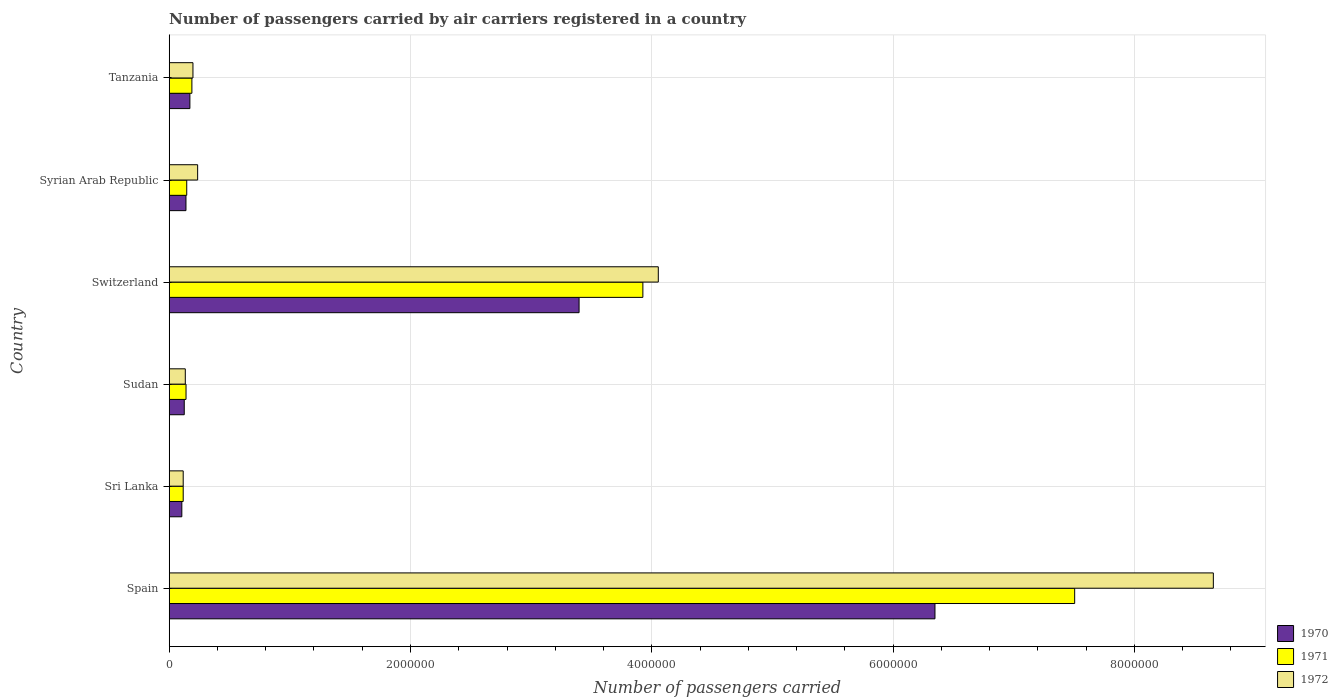Are the number of bars on each tick of the Y-axis equal?
Make the answer very short. Yes. How many bars are there on the 4th tick from the bottom?
Provide a short and direct response. 3. What is the label of the 4th group of bars from the top?
Offer a very short reply. Sudan. What is the number of passengers carried by air carriers in 1972 in Syrian Arab Republic?
Your response must be concise. 2.36e+05. Across all countries, what is the maximum number of passengers carried by air carriers in 1971?
Make the answer very short. 7.51e+06. Across all countries, what is the minimum number of passengers carried by air carriers in 1970?
Your response must be concise. 1.05e+05. In which country was the number of passengers carried by air carriers in 1971 minimum?
Give a very brief answer. Sri Lanka. What is the total number of passengers carried by air carriers in 1970 in the graph?
Make the answer very short. 1.03e+07. What is the difference between the number of passengers carried by air carriers in 1972 in Switzerland and that in Tanzania?
Keep it short and to the point. 3.86e+06. What is the difference between the number of passengers carried by air carriers in 1972 in Sri Lanka and the number of passengers carried by air carriers in 1971 in Syrian Arab Republic?
Offer a terse response. -2.93e+04. What is the average number of passengers carried by air carriers in 1971 per country?
Your response must be concise. 2.00e+06. What is the difference between the number of passengers carried by air carriers in 1970 and number of passengers carried by air carriers in 1972 in Syrian Arab Republic?
Make the answer very short. -9.67e+04. In how many countries, is the number of passengers carried by air carriers in 1970 greater than 7200000 ?
Ensure brevity in your answer.  0. What is the ratio of the number of passengers carried by air carriers in 1972 in Spain to that in Syrian Arab Republic?
Your answer should be very brief. 36.72. Is the difference between the number of passengers carried by air carriers in 1970 in Sudan and Switzerland greater than the difference between the number of passengers carried by air carriers in 1972 in Sudan and Switzerland?
Offer a very short reply. Yes. What is the difference between the highest and the second highest number of passengers carried by air carriers in 1970?
Provide a succinct answer. 2.95e+06. What is the difference between the highest and the lowest number of passengers carried by air carriers in 1970?
Your response must be concise. 6.24e+06. In how many countries, is the number of passengers carried by air carriers in 1970 greater than the average number of passengers carried by air carriers in 1970 taken over all countries?
Provide a short and direct response. 2. What is the difference between two consecutive major ticks on the X-axis?
Keep it short and to the point. 2.00e+06. Are the values on the major ticks of X-axis written in scientific E-notation?
Your answer should be very brief. No. Does the graph contain grids?
Your answer should be very brief. Yes. What is the title of the graph?
Offer a terse response. Number of passengers carried by air carriers registered in a country. What is the label or title of the X-axis?
Offer a very short reply. Number of passengers carried. What is the label or title of the Y-axis?
Give a very brief answer. Country. What is the Number of passengers carried of 1970 in Spain?
Make the answer very short. 6.35e+06. What is the Number of passengers carried in 1971 in Spain?
Provide a succinct answer. 7.51e+06. What is the Number of passengers carried of 1972 in Spain?
Keep it short and to the point. 8.65e+06. What is the Number of passengers carried of 1970 in Sri Lanka?
Your response must be concise. 1.05e+05. What is the Number of passengers carried of 1971 in Sri Lanka?
Keep it short and to the point. 1.16e+05. What is the Number of passengers carried in 1972 in Sri Lanka?
Give a very brief answer. 1.16e+05. What is the Number of passengers carried in 1970 in Sudan?
Give a very brief answer. 1.25e+05. What is the Number of passengers carried in 1971 in Sudan?
Your response must be concise. 1.40e+05. What is the Number of passengers carried in 1972 in Sudan?
Make the answer very short. 1.33e+05. What is the Number of passengers carried of 1970 in Switzerland?
Your answer should be compact. 3.40e+06. What is the Number of passengers carried in 1971 in Switzerland?
Offer a terse response. 3.93e+06. What is the Number of passengers carried in 1972 in Switzerland?
Offer a very short reply. 4.05e+06. What is the Number of passengers carried in 1970 in Syrian Arab Republic?
Provide a succinct answer. 1.39e+05. What is the Number of passengers carried of 1971 in Syrian Arab Republic?
Ensure brevity in your answer.  1.45e+05. What is the Number of passengers carried of 1972 in Syrian Arab Republic?
Provide a short and direct response. 2.36e+05. What is the Number of passengers carried in 1970 in Tanzania?
Offer a terse response. 1.71e+05. What is the Number of passengers carried of 1971 in Tanzania?
Keep it short and to the point. 1.88e+05. What is the Number of passengers carried of 1972 in Tanzania?
Ensure brevity in your answer.  1.97e+05. Across all countries, what is the maximum Number of passengers carried of 1970?
Your answer should be compact. 6.35e+06. Across all countries, what is the maximum Number of passengers carried in 1971?
Your response must be concise. 7.51e+06. Across all countries, what is the maximum Number of passengers carried of 1972?
Your response must be concise. 8.65e+06. Across all countries, what is the minimum Number of passengers carried in 1970?
Your answer should be very brief. 1.05e+05. Across all countries, what is the minimum Number of passengers carried in 1971?
Give a very brief answer. 1.16e+05. Across all countries, what is the minimum Number of passengers carried in 1972?
Provide a short and direct response. 1.16e+05. What is the total Number of passengers carried in 1970 in the graph?
Offer a very short reply. 1.03e+07. What is the total Number of passengers carried in 1971 in the graph?
Provide a succinct answer. 1.20e+07. What is the total Number of passengers carried in 1972 in the graph?
Keep it short and to the point. 1.34e+07. What is the difference between the Number of passengers carried of 1970 in Spain and that in Sri Lanka?
Offer a very short reply. 6.24e+06. What is the difference between the Number of passengers carried of 1971 in Spain and that in Sri Lanka?
Your response must be concise. 7.39e+06. What is the difference between the Number of passengers carried in 1972 in Spain and that in Sri Lanka?
Make the answer very short. 8.54e+06. What is the difference between the Number of passengers carried in 1970 in Spain and that in Sudan?
Provide a succinct answer. 6.22e+06. What is the difference between the Number of passengers carried of 1971 in Spain and that in Sudan?
Keep it short and to the point. 7.37e+06. What is the difference between the Number of passengers carried in 1972 in Spain and that in Sudan?
Ensure brevity in your answer.  8.52e+06. What is the difference between the Number of passengers carried of 1970 in Spain and that in Switzerland?
Your answer should be very brief. 2.95e+06. What is the difference between the Number of passengers carried in 1971 in Spain and that in Switzerland?
Give a very brief answer. 3.58e+06. What is the difference between the Number of passengers carried of 1972 in Spain and that in Switzerland?
Offer a very short reply. 4.60e+06. What is the difference between the Number of passengers carried in 1970 in Spain and that in Syrian Arab Republic?
Your answer should be very brief. 6.21e+06. What is the difference between the Number of passengers carried in 1971 in Spain and that in Syrian Arab Republic?
Provide a short and direct response. 7.36e+06. What is the difference between the Number of passengers carried in 1972 in Spain and that in Syrian Arab Republic?
Offer a very short reply. 8.42e+06. What is the difference between the Number of passengers carried in 1970 in Spain and that in Tanzania?
Ensure brevity in your answer.  6.18e+06. What is the difference between the Number of passengers carried in 1971 in Spain and that in Tanzania?
Offer a terse response. 7.32e+06. What is the difference between the Number of passengers carried in 1972 in Spain and that in Tanzania?
Offer a very short reply. 8.46e+06. What is the difference between the Number of passengers carried of 1970 in Sri Lanka and that in Sudan?
Ensure brevity in your answer.  -2.01e+04. What is the difference between the Number of passengers carried of 1971 in Sri Lanka and that in Sudan?
Ensure brevity in your answer.  -2.35e+04. What is the difference between the Number of passengers carried of 1972 in Sri Lanka and that in Sudan?
Give a very brief answer. -1.74e+04. What is the difference between the Number of passengers carried in 1970 in Sri Lanka and that in Switzerland?
Make the answer very short. -3.29e+06. What is the difference between the Number of passengers carried of 1971 in Sri Lanka and that in Switzerland?
Ensure brevity in your answer.  -3.81e+06. What is the difference between the Number of passengers carried in 1972 in Sri Lanka and that in Switzerland?
Provide a short and direct response. -3.94e+06. What is the difference between the Number of passengers carried in 1970 in Sri Lanka and that in Syrian Arab Republic?
Your response must be concise. -3.44e+04. What is the difference between the Number of passengers carried in 1971 in Sri Lanka and that in Syrian Arab Republic?
Your answer should be compact. -2.93e+04. What is the difference between the Number of passengers carried of 1972 in Sri Lanka and that in Syrian Arab Republic?
Offer a very short reply. -1.20e+05. What is the difference between the Number of passengers carried of 1970 in Sri Lanka and that in Tanzania?
Give a very brief answer. -6.68e+04. What is the difference between the Number of passengers carried of 1971 in Sri Lanka and that in Tanzania?
Provide a short and direct response. -7.20e+04. What is the difference between the Number of passengers carried in 1972 in Sri Lanka and that in Tanzania?
Keep it short and to the point. -8.09e+04. What is the difference between the Number of passengers carried in 1970 in Sudan and that in Switzerland?
Make the answer very short. -3.27e+06. What is the difference between the Number of passengers carried in 1971 in Sudan and that in Switzerland?
Provide a succinct answer. -3.79e+06. What is the difference between the Number of passengers carried in 1972 in Sudan and that in Switzerland?
Keep it short and to the point. -3.92e+06. What is the difference between the Number of passengers carried in 1970 in Sudan and that in Syrian Arab Republic?
Provide a succinct answer. -1.43e+04. What is the difference between the Number of passengers carried of 1971 in Sudan and that in Syrian Arab Republic?
Offer a terse response. -5800. What is the difference between the Number of passengers carried of 1972 in Sudan and that in Syrian Arab Republic?
Offer a terse response. -1.02e+05. What is the difference between the Number of passengers carried of 1970 in Sudan and that in Tanzania?
Ensure brevity in your answer.  -4.67e+04. What is the difference between the Number of passengers carried in 1971 in Sudan and that in Tanzania?
Provide a short and direct response. -4.85e+04. What is the difference between the Number of passengers carried of 1972 in Sudan and that in Tanzania?
Offer a very short reply. -6.35e+04. What is the difference between the Number of passengers carried of 1970 in Switzerland and that in Syrian Arab Republic?
Offer a terse response. 3.26e+06. What is the difference between the Number of passengers carried of 1971 in Switzerland and that in Syrian Arab Republic?
Ensure brevity in your answer.  3.78e+06. What is the difference between the Number of passengers carried of 1972 in Switzerland and that in Syrian Arab Republic?
Your answer should be very brief. 3.82e+06. What is the difference between the Number of passengers carried in 1970 in Switzerland and that in Tanzania?
Keep it short and to the point. 3.23e+06. What is the difference between the Number of passengers carried in 1971 in Switzerland and that in Tanzania?
Offer a terse response. 3.74e+06. What is the difference between the Number of passengers carried of 1972 in Switzerland and that in Tanzania?
Keep it short and to the point. 3.86e+06. What is the difference between the Number of passengers carried in 1970 in Syrian Arab Republic and that in Tanzania?
Ensure brevity in your answer.  -3.24e+04. What is the difference between the Number of passengers carried in 1971 in Syrian Arab Republic and that in Tanzania?
Offer a terse response. -4.27e+04. What is the difference between the Number of passengers carried in 1972 in Syrian Arab Republic and that in Tanzania?
Ensure brevity in your answer.  3.88e+04. What is the difference between the Number of passengers carried in 1970 in Spain and the Number of passengers carried in 1971 in Sri Lanka?
Ensure brevity in your answer.  6.23e+06. What is the difference between the Number of passengers carried in 1970 in Spain and the Number of passengers carried in 1972 in Sri Lanka?
Offer a very short reply. 6.23e+06. What is the difference between the Number of passengers carried in 1971 in Spain and the Number of passengers carried in 1972 in Sri Lanka?
Your answer should be compact. 7.39e+06. What is the difference between the Number of passengers carried in 1970 in Spain and the Number of passengers carried in 1971 in Sudan?
Offer a terse response. 6.21e+06. What is the difference between the Number of passengers carried in 1970 in Spain and the Number of passengers carried in 1972 in Sudan?
Make the answer very short. 6.21e+06. What is the difference between the Number of passengers carried of 1971 in Spain and the Number of passengers carried of 1972 in Sudan?
Your answer should be very brief. 7.37e+06. What is the difference between the Number of passengers carried of 1970 in Spain and the Number of passengers carried of 1971 in Switzerland?
Give a very brief answer. 2.42e+06. What is the difference between the Number of passengers carried in 1970 in Spain and the Number of passengers carried in 1972 in Switzerland?
Your answer should be very brief. 2.29e+06. What is the difference between the Number of passengers carried of 1971 in Spain and the Number of passengers carried of 1972 in Switzerland?
Your response must be concise. 3.45e+06. What is the difference between the Number of passengers carried in 1970 in Spain and the Number of passengers carried in 1971 in Syrian Arab Republic?
Give a very brief answer. 6.20e+06. What is the difference between the Number of passengers carried of 1970 in Spain and the Number of passengers carried of 1972 in Syrian Arab Republic?
Provide a short and direct response. 6.11e+06. What is the difference between the Number of passengers carried in 1971 in Spain and the Number of passengers carried in 1972 in Syrian Arab Republic?
Give a very brief answer. 7.27e+06. What is the difference between the Number of passengers carried of 1970 in Spain and the Number of passengers carried of 1971 in Tanzania?
Ensure brevity in your answer.  6.16e+06. What is the difference between the Number of passengers carried in 1970 in Spain and the Number of passengers carried in 1972 in Tanzania?
Offer a very short reply. 6.15e+06. What is the difference between the Number of passengers carried in 1971 in Spain and the Number of passengers carried in 1972 in Tanzania?
Offer a very short reply. 7.31e+06. What is the difference between the Number of passengers carried of 1970 in Sri Lanka and the Number of passengers carried of 1971 in Sudan?
Make the answer very short. -3.49e+04. What is the difference between the Number of passengers carried of 1970 in Sri Lanka and the Number of passengers carried of 1972 in Sudan?
Provide a short and direct response. -2.88e+04. What is the difference between the Number of passengers carried of 1971 in Sri Lanka and the Number of passengers carried of 1972 in Sudan?
Offer a very short reply. -1.74e+04. What is the difference between the Number of passengers carried of 1970 in Sri Lanka and the Number of passengers carried of 1971 in Switzerland?
Offer a very short reply. -3.82e+06. What is the difference between the Number of passengers carried of 1970 in Sri Lanka and the Number of passengers carried of 1972 in Switzerland?
Ensure brevity in your answer.  -3.95e+06. What is the difference between the Number of passengers carried of 1971 in Sri Lanka and the Number of passengers carried of 1972 in Switzerland?
Make the answer very short. -3.94e+06. What is the difference between the Number of passengers carried in 1970 in Sri Lanka and the Number of passengers carried in 1971 in Syrian Arab Republic?
Offer a terse response. -4.07e+04. What is the difference between the Number of passengers carried of 1970 in Sri Lanka and the Number of passengers carried of 1972 in Syrian Arab Republic?
Offer a terse response. -1.31e+05. What is the difference between the Number of passengers carried of 1971 in Sri Lanka and the Number of passengers carried of 1972 in Syrian Arab Republic?
Ensure brevity in your answer.  -1.20e+05. What is the difference between the Number of passengers carried of 1970 in Sri Lanka and the Number of passengers carried of 1971 in Tanzania?
Your answer should be very brief. -8.34e+04. What is the difference between the Number of passengers carried in 1970 in Sri Lanka and the Number of passengers carried in 1972 in Tanzania?
Provide a short and direct response. -9.23e+04. What is the difference between the Number of passengers carried in 1971 in Sri Lanka and the Number of passengers carried in 1972 in Tanzania?
Your answer should be very brief. -8.09e+04. What is the difference between the Number of passengers carried in 1970 in Sudan and the Number of passengers carried in 1971 in Switzerland?
Provide a short and direct response. -3.80e+06. What is the difference between the Number of passengers carried of 1970 in Sudan and the Number of passengers carried of 1972 in Switzerland?
Make the answer very short. -3.93e+06. What is the difference between the Number of passengers carried of 1971 in Sudan and the Number of passengers carried of 1972 in Switzerland?
Make the answer very short. -3.91e+06. What is the difference between the Number of passengers carried of 1970 in Sudan and the Number of passengers carried of 1971 in Syrian Arab Republic?
Provide a succinct answer. -2.06e+04. What is the difference between the Number of passengers carried of 1970 in Sudan and the Number of passengers carried of 1972 in Syrian Arab Republic?
Keep it short and to the point. -1.11e+05. What is the difference between the Number of passengers carried in 1971 in Sudan and the Number of passengers carried in 1972 in Syrian Arab Republic?
Provide a succinct answer. -9.62e+04. What is the difference between the Number of passengers carried in 1970 in Sudan and the Number of passengers carried in 1971 in Tanzania?
Provide a succinct answer. -6.33e+04. What is the difference between the Number of passengers carried of 1970 in Sudan and the Number of passengers carried of 1972 in Tanzania?
Provide a short and direct response. -7.22e+04. What is the difference between the Number of passengers carried in 1971 in Sudan and the Number of passengers carried in 1972 in Tanzania?
Your answer should be very brief. -5.74e+04. What is the difference between the Number of passengers carried in 1970 in Switzerland and the Number of passengers carried in 1971 in Syrian Arab Republic?
Make the answer very short. 3.25e+06. What is the difference between the Number of passengers carried of 1970 in Switzerland and the Number of passengers carried of 1972 in Syrian Arab Republic?
Provide a succinct answer. 3.16e+06. What is the difference between the Number of passengers carried in 1971 in Switzerland and the Number of passengers carried in 1972 in Syrian Arab Republic?
Ensure brevity in your answer.  3.69e+06. What is the difference between the Number of passengers carried in 1970 in Switzerland and the Number of passengers carried in 1971 in Tanzania?
Offer a terse response. 3.21e+06. What is the difference between the Number of passengers carried of 1970 in Switzerland and the Number of passengers carried of 1972 in Tanzania?
Make the answer very short. 3.20e+06. What is the difference between the Number of passengers carried of 1971 in Switzerland and the Number of passengers carried of 1972 in Tanzania?
Give a very brief answer. 3.73e+06. What is the difference between the Number of passengers carried of 1970 in Syrian Arab Republic and the Number of passengers carried of 1971 in Tanzania?
Give a very brief answer. -4.90e+04. What is the difference between the Number of passengers carried in 1970 in Syrian Arab Republic and the Number of passengers carried in 1972 in Tanzania?
Offer a terse response. -5.79e+04. What is the difference between the Number of passengers carried of 1971 in Syrian Arab Republic and the Number of passengers carried of 1972 in Tanzania?
Your answer should be very brief. -5.16e+04. What is the average Number of passengers carried in 1970 per country?
Offer a terse response. 1.71e+06. What is the average Number of passengers carried in 1971 per country?
Provide a succinct answer. 2.00e+06. What is the average Number of passengers carried of 1972 per country?
Give a very brief answer. 2.23e+06. What is the difference between the Number of passengers carried in 1970 and Number of passengers carried in 1971 in Spain?
Give a very brief answer. -1.16e+06. What is the difference between the Number of passengers carried of 1970 and Number of passengers carried of 1972 in Spain?
Your answer should be compact. -2.31e+06. What is the difference between the Number of passengers carried in 1971 and Number of passengers carried in 1972 in Spain?
Ensure brevity in your answer.  -1.15e+06. What is the difference between the Number of passengers carried in 1970 and Number of passengers carried in 1971 in Sri Lanka?
Your response must be concise. -1.14e+04. What is the difference between the Number of passengers carried in 1970 and Number of passengers carried in 1972 in Sri Lanka?
Provide a short and direct response. -1.14e+04. What is the difference between the Number of passengers carried in 1971 and Number of passengers carried in 1972 in Sri Lanka?
Make the answer very short. 0. What is the difference between the Number of passengers carried of 1970 and Number of passengers carried of 1971 in Sudan?
Keep it short and to the point. -1.48e+04. What is the difference between the Number of passengers carried in 1970 and Number of passengers carried in 1972 in Sudan?
Your answer should be very brief. -8700. What is the difference between the Number of passengers carried in 1971 and Number of passengers carried in 1972 in Sudan?
Give a very brief answer. 6100. What is the difference between the Number of passengers carried in 1970 and Number of passengers carried in 1971 in Switzerland?
Your answer should be very brief. -5.29e+05. What is the difference between the Number of passengers carried in 1970 and Number of passengers carried in 1972 in Switzerland?
Give a very brief answer. -6.57e+05. What is the difference between the Number of passengers carried of 1971 and Number of passengers carried of 1972 in Switzerland?
Make the answer very short. -1.28e+05. What is the difference between the Number of passengers carried of 1970 and Number of passengers carried of 1971 in Syrian Arab Republic?
Offer a terse response. -6300. What is the difference between the Number of passengers carried in 1970 and Number of passengers carried in 1972 in Syrian Arab Republic?
Your answer should be compact. -9.67e+04. What is the difference between the Number of passengers carried in 1971 and Number of passengers carried in 1972 in Syrian Arab Republic?
Make the answer very short. -9.04e+04. What is the difference between the Number of passengers carried in 1970 and Number of passengers carried in 1971 in Tanzania?
Provide a succinct answer. -1.66e+04. What is the difference between the Number of passengers carried in 1970 and Number of passengers carried in 1972 in Tanzania?
Provide a short and direct response. -2.55e+04. What is the difference between the Number of passengers carried in 1971 and Number of passengers carried in 1972 in Tanzania?
Keep it short and to the point. -8900. What is the ratio of the Number of passengers carried in 1970 in Spain to that in Sri Lanka?
Your answer should be very brief. 60.68. What is the ratio of the Number of passengers carried in 1971 in Spain to that in Sri Lanka?
Your answer should be compact. 64.7. What is the ratio of the Number of passengers carried in 1972 in Spain to that in Sri Lanka?
Provide a succinct answer. 74.61. What is the ratio of the Number of passengers carried in 1970 in Spain to that in Sudan?
Ensure brevity in your answer.  50.9. What is the ratio of the Number of passengers carried in 1971 in Spain to that in Sudan?
Keep it short and to the point. 53.8. What is the ratio of the Number of passengers carried of 1972 in Spain to that in Sudan?
Give a very brief answer. 64.88. What is the ratio of the Number of passengers carried of 1970 in Spain to that in Switzerland?
Offer a terse response. 1.87. What is the ratio of the Number of passengers carried in 1971 in Spain to that in Switzerland?
Ensure brevity in your answer.  1.91. What is the ratio of the Number of passengers carried of 1972 in Spain to that in Switzerland?
Make the answer very short. 2.13. What is the ratio of the Number of passengers carried in 1970 in Spain to that in Syrian Arab Republic?
Provide a short and direct response. 45.66. What is the ratio of the Number of passengers carried of 1971 in Spain to that in Syrian Arab Republic?
Your answer should be compact. 51.65. What is the ratio of the Number of passengers carried in 1972 in Spain to that in Syrian Arab Republic?
Offer a terse response. 36.72. What is the ratio of the Number of passengers carried in 1970 in Spain to that in Tanzania?
Offer a terse response. 37.03. What is the ratio of the Number of passengers carried of 1971 in Spain to that in Tanzania?
Offer a very short reply. 39.92. What is the ratio of the Number of passengers carried in 1972 in Spain to that in Tanzania?
Ensure brevity in your answer.  43.96. What is the ratio of the Number of passengers carried in 1970 in Sri Lanka to that in Sudan?
Give a very brief answer. 0.84. What is the ratio of the Number of passengers carried of 1971 in Sri Lanka to that in Sudan?
Your answer should be compact. 0.83. What is the ratio of the Number of passengers carried in 1972 in Sri Lanka to that in Sudan?
Your response must be concise. 0.87. What is the ratio of the Number of passengers carried in 1970 in Sri Lanka to that in Switzerland?
Keep it short and to the point. 0.03. What is the ratio of the Number of passengers carried of 1971 in Sri Lanka to that in Switzerland?
Provide a succinct answer. 0.03. What is the ratio of the Number of passengers carried in 1972 in Sri Lanka to that in Switzerland?
Offer a terse response. 0.03. What is the ratio of the Number of passengers carried in 1970 in Sri Lanka to that in Syrian Arab Republic?
Keep it short and to the point. 0.75. What is the ratio of the Number of passengers carried in 1971 in Sri Lanka to that in Syrian Arab Republic?
Keep it short and to the point. 0.8. What is the ratio of the Number of passengers carried in 1972 in Sri Lanka to that in Syrian Arab Republic?
Your answer should be compact. 0.49. What is the ratio of the Number of passengers carried of 1970 in Sri Lanka to that in Tanzania?
Offer a terse response. 0.61. What is the ratio of the Number of passengers carried of 1971 in Sri Lanka to that in Tanzania?
Offer a very short reply. 0.62. What is the ratio of the Number of passengers carried in 1972 in Sri Lanka to that in Tanzania?
Your answer should be very brief. 0.59. What is the ratio of the Number of passengers carried of 1970 in Sudan to that in Switzerland?
Give a very brief answer. 0.04. What is the ratio of the Number of passengers carried of 1971 in Sudan to that in Switzerland?
Give a very brief answer. 0.04. What is the ratio of the Number of passengers carried of 1972 in Sudan to that in Switzerland?
Offer a terse response. 0.03. What is the ratio of the Number of passengers carried in 1970 in Sudan to that in Syrian Arab Republic?
Ensure brevity in your answer.  0.9. What is the ratio of the Number of passengers carried of 1971 in Sudan to that in Syrian Arab Republic?
Your answer should be compact. 0.96. What is the ratio of the Number of passengers carried in 1972 in Sudan to that in Syrian Arab Republic?
Ensure brevity in your answer.  0.57. What is the ratio of the Number of passengers carried in 1970 in Sudan to that in Tanzania?
Provide a succinct answer. 0.73. What is the ratio of the Number of passengers carried of 1971 in Sudan to that in Tanzania?
Keep it short and to the point. 0.74. What is the ratio of the Number of passengers carried in 1972 in Sudan to that in Tanzania?
Make the answer very short. 0.68. What is the ratio of the Number of passengers carried of 1970 in Switzerland to that in Syrian Arab Republic?
Your response must be concise. 24.44. What is the ratio of the Number of passengers carried of 1971 in Switzerland to that in Syrian Arab Republic?
Give a very brief answer. 27.02. What is the ratio of the Number of passengers carried in 1972 in Switzerland to that in Syrian Arab Republic?
Your answer should be compact. 17.2. What is the ratio of the Number of passengers carried of 1970 in Switzerland to that in Tanzania?
Your answer should be compact. 19.82. What is the ratio of the Number of passengers carried of 1971 in Switzerland to that in Tanzania?
Offer a terse response. 20.88. What is the ratio of the Number of passengers carried in 1972 in Switzerland to that in Tanzania?
Keep it short and to the point. 20.59. What is the ratio of the Number of passengers carried of 1970 in Syrian Arab Republic to that in Tanzania?
Give a very brief answer. 0.81. What is the ratio of the Number of passengers carried in 1971 in Syrian Arab Republic to that in Tanzania?
Provide a short and direct response. 0.77. What is the ratio of the Number of passengers carried in 1972 in Syrian Arab Republic to that in Tanzania?
Give a very brief answer. 1.2. What is the difference between the highest and the second highest Number of passengers carried of 1970?
Provide a succinct answer. 2.95e+06. What is the difference between the highest and the second highest Number of passengers carried in 1971?
Offer a very short reply. 3.58e+06. What is the difference between the highest and the second highest Number of passengers carried of 1972?
Your answer should be very brief. 4.60e+06. What is the difference between the highest and the lowest Number of passengers carried of 1970?
Provide a short and direct response. 6.24e+06. What is the difference between the highest and the lowest Number of passengers carried of 1971?
Keep it short and to the point. 7.39e+06. What is the difference between the highest and the lowest Number of passengers carried of 1972?
Make the answer very short. 8.54e+06. 